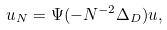<formula> <loc_0><loc_0><loc_500><loc_500>u _ { N } = \Psi ( - N ^ { - 2 } \Delta _ { D } ) u ,</formula> 